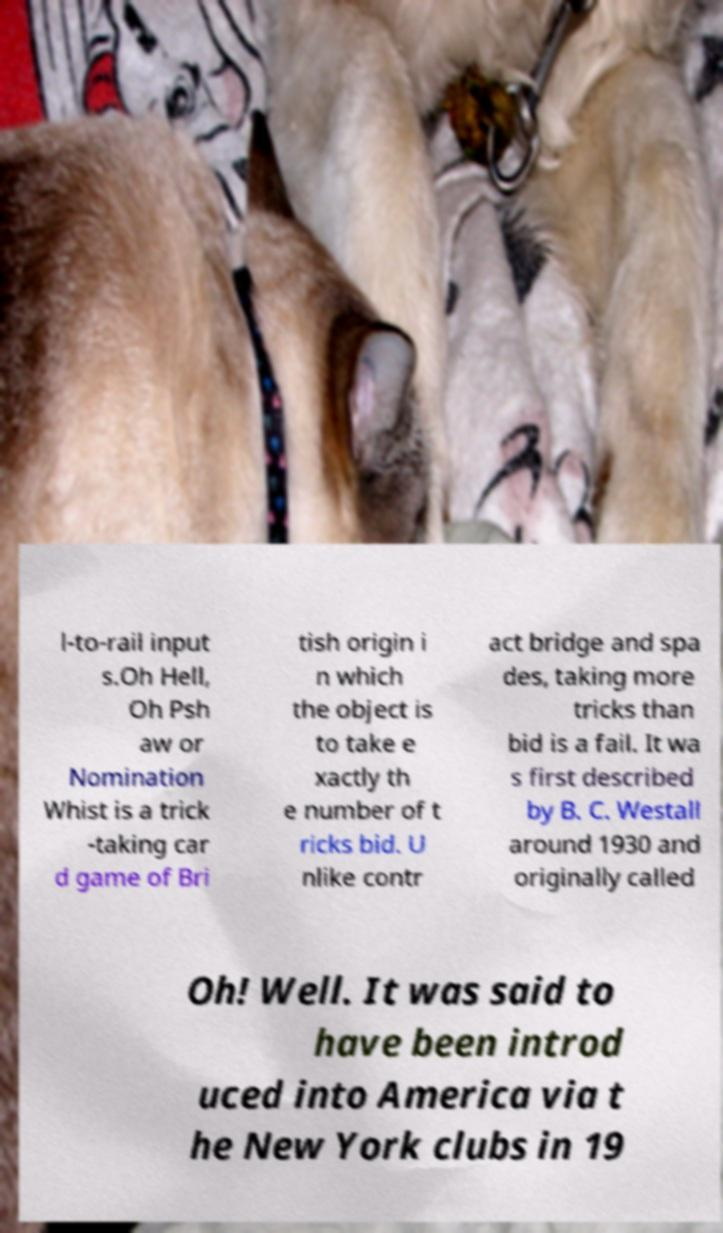Please read and relay the text visible in this image. What does it say? l-to-rail input s.Oh Hell, Oh Psh aw or Nomination Whist is a trick -taking car d game of Bri tish origin i n which the object is to take e xactly th e number of t ricks bid. U nlike contr act bridge and spa des, taking more tricks than bid is a fail. It wa s first described by B. C. Westall around 1930 and originally called Oh! Well. It was said to have been introd uced into America via t he New York clubs in 19 